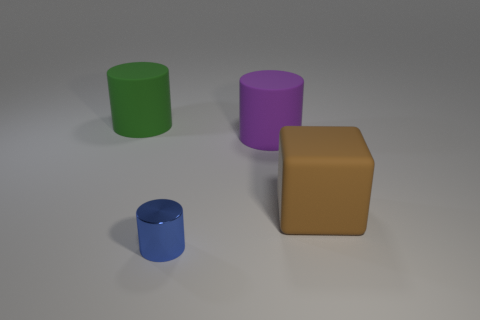What number of objects are big matte cylinders on the left side of the purple cylinder or large brown objects?
Offer a very short reply. 2. There is another large matte object that is the same shape as the big green matte thing; what is its color?
Provide a succinct answer. Purple. Is there anything else that is the same color as the tiny object?
Give a very brief answer. No. How big is the matte cylinder that is to the right of the tiny metallic cylinder?
Make the answer very short. Large. There is a metallic object; does it have the same color as the large rubber cylinder that is left of the tiny cylinder?
Offer a very short reply. No. How many other things are the same material as the big cube?
Ensure brevity in your answer.  2. Is the number of blue things greater than the number of tiny cyan rubber cylinders?
Your answer should be very brief. Yes. Does the cylinder right of the shiny object have the same color as the small shiny thing?
Provide a short and direct response. No. The big block is what color?
Your answer should be compact. Brown. There is a object that is in front of the block; is there a thing that is to the left of it?
Ensure brevity in your answer.  Yes. 